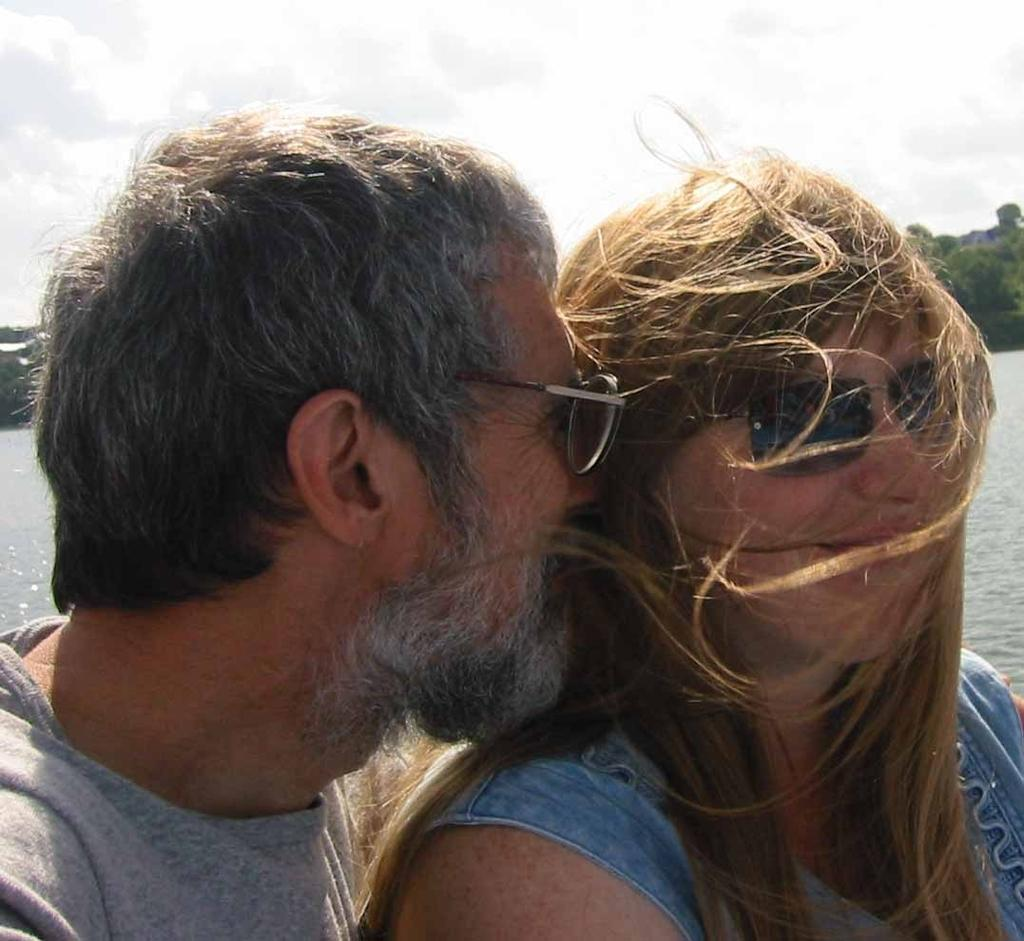What is the gender of the person in the image? There is a man in the image. Can you describe the man's appearance? The man is wearing glasses. Are there any other people in the image? Yes, there is a lady in the image. How does the lady in the image appear? The lady is wearing glasses as well. What can be seen in the background of the image? There is water, trees, and the sky visible in the background of the image. What number is written on the man's shirt in the image? There is no number visible on the man's shirt in the image. Is the image taken during the summer season? The provided facts do not mention the season or weather, so it cannot be determined from the image. 